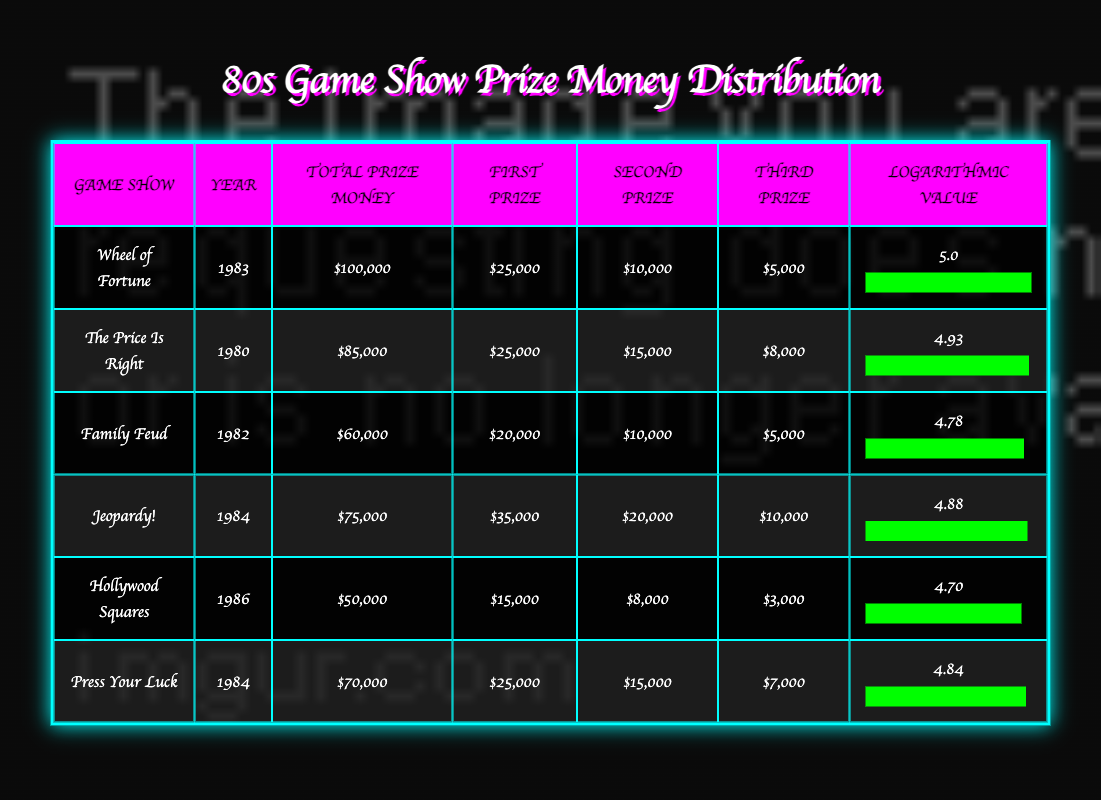What is the total prize money for "Wheel of Fortune"? The table lists "Wheel of Fortune" under the "Total Prize Money" column, showing it as $100,000.
Answer: $100,000 Which game show had the highest first prize amount in the 80s? Looking at the "First Prize" amounts, "Jeopardy!" has the highest prize listed at $35,000.
Answer: $35,000 Was the total prize money for "Family Feud" greater than $65,000? "Family Feud" has a total prize money of $60,000, which is less than $65,000, so the answer is no.
Answer: No What is the average total prize money for the game shows listed? The total prize money from all game shows is $100,000 + $85,000 + $60,000 + $75,000 + $50,000 + $70,000 = $440,000. There are 6 game shows, so the average is $440,000 / 6 = $73,333.33, which rounds to $73,333.
Answer: $73,333 Which two game shows together had a total prize money of at least $150,000? "Wheel of Fortune" has $100,000 and "The Price Is Right" has $85,000. Combining these gives $100,000 + $85,000 = $185,000, which is greater than $150,000. Therefore, they qualify.
Answer: Yes What is the difference in total prize money between the highest and lowest game shows? "Wheel of Fortune" has the highest total prize money at $100,000, and "Hollywood Squares" has the lowest at $50,000. The difference is $100,000 - $50,000 = $50,000.
Answer: $50,000 True or false: "Press Your Luck" had a higher second prize than "Family Feud". "Press Your Luck" has a second prize of $15,000, while "Family Feud" has a second prize of $10,000. Since $15,000 is greater than $10,000, the statement is true.
Answer: True Which game show had a logarithmic value closest to 5? Reviewing the logarithmic values, "Wheel of Fortune" has a logarithmic value of 5.0, and it's the only show with a value that rounds closest to 5.
Answer: Wheel of Fortune If we combine the prize money of "Jeopardy!" and "Press Your Luck", what is the total? The total prize for "Jeopardy!" is $75,000 and for "Press Your Luck" is $70,000. Combining them gives $75,000 + $70,000 = $145,000.
Answer: $145,000 